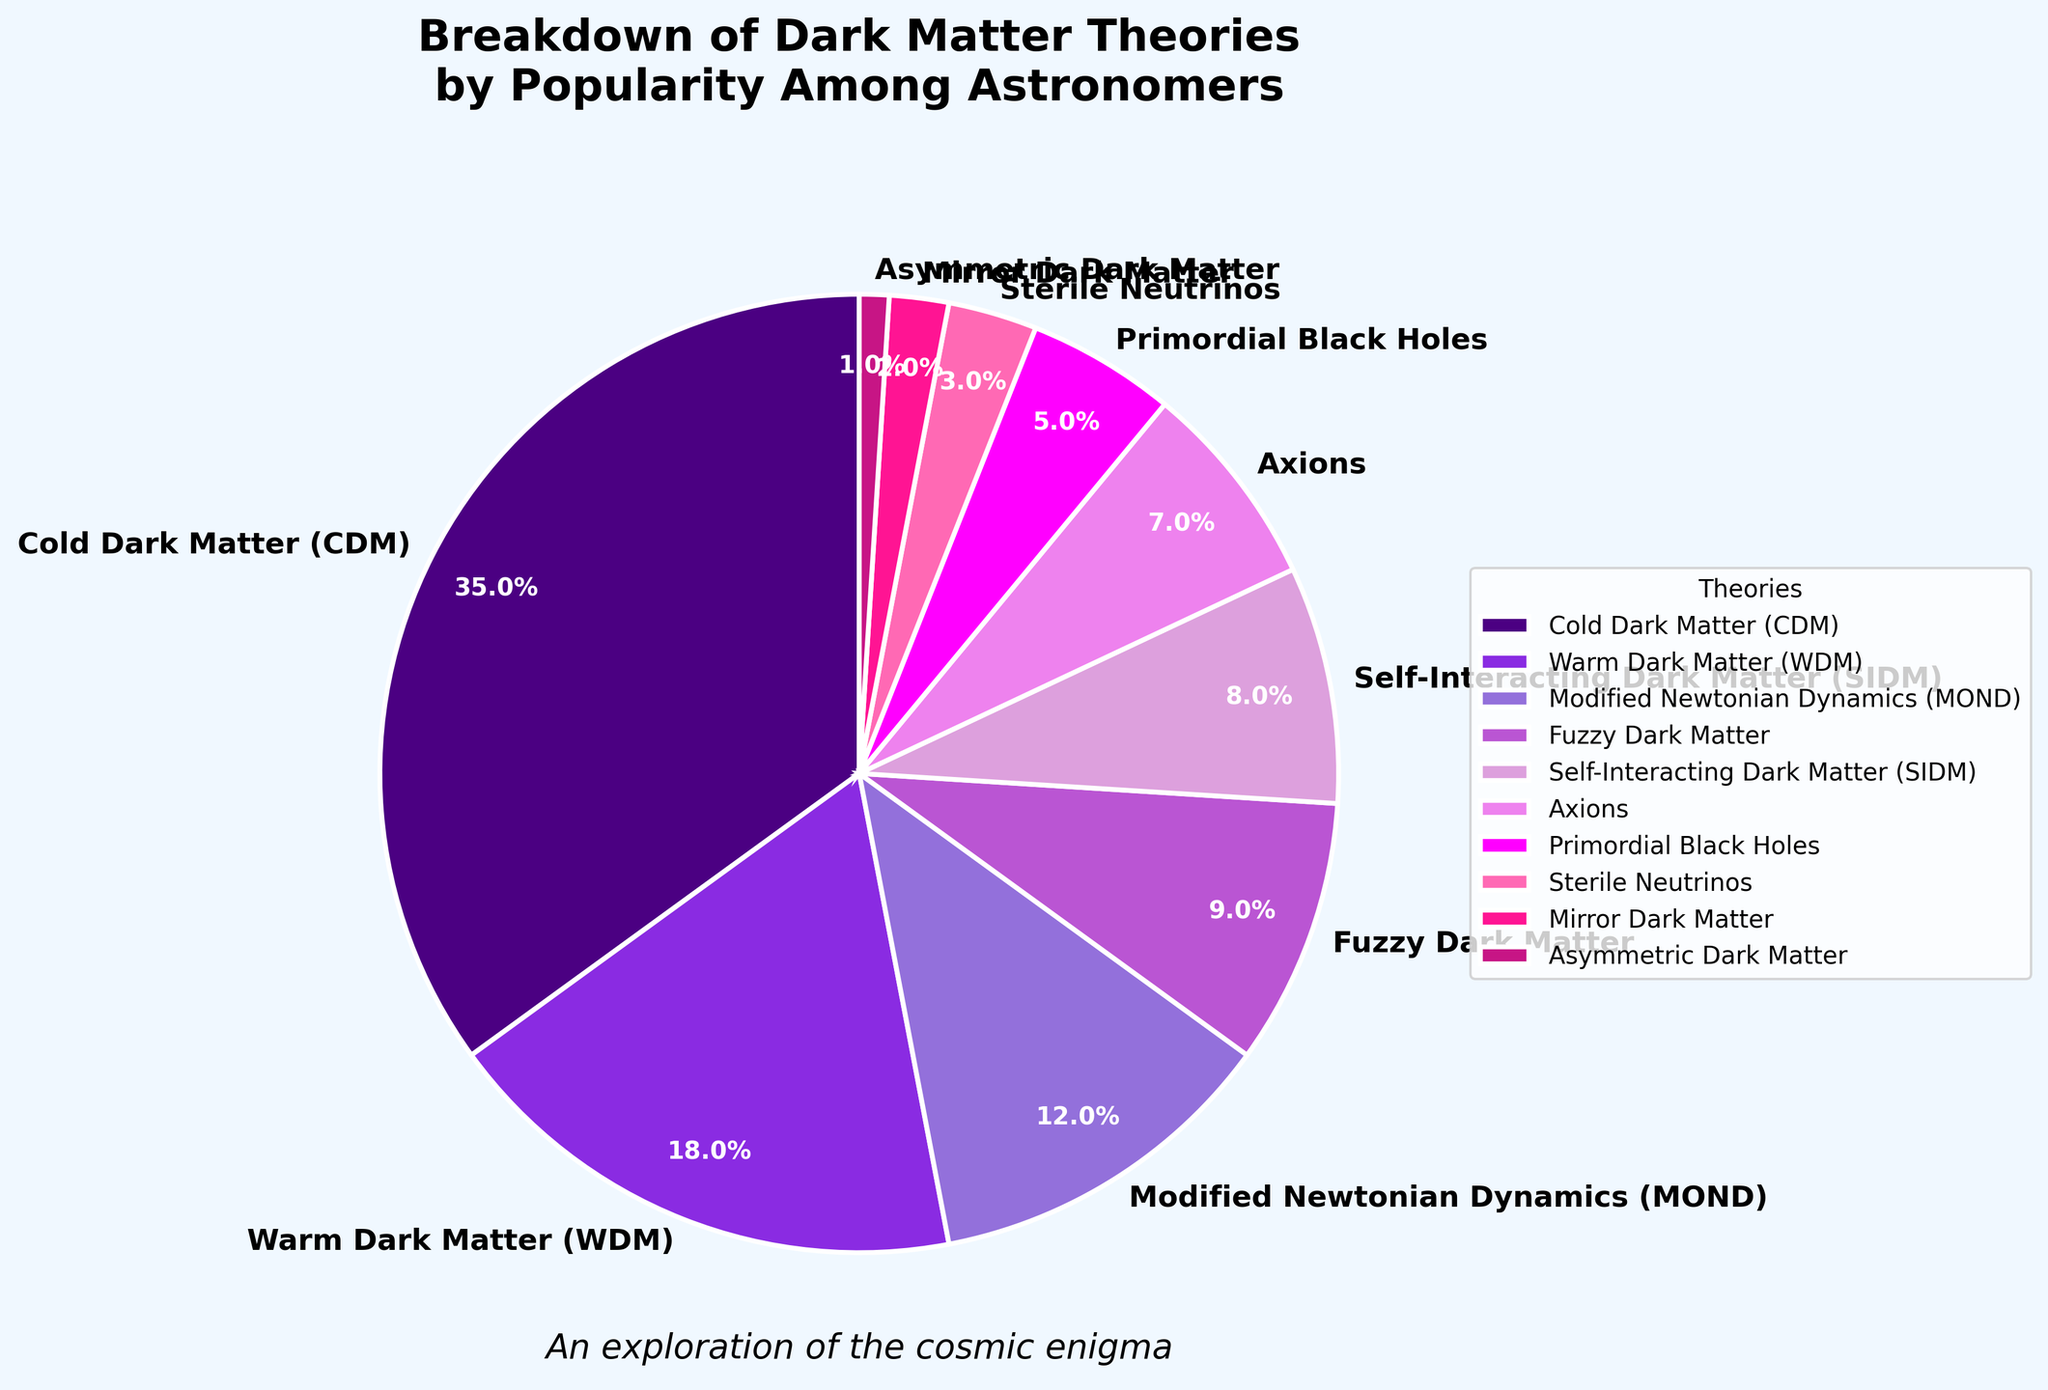What's the most popular dark matter theory? The slice of the pie chart labeled "Cold Dark Matter (CDM)" takes up the largest portion of the chart.
Answer: Cold Dark Matter (CDM) Which two theories together make up less than 5% of the pie chart? The slices labeled "Mirror Dark Matter" and "Asymmetric Dark Matter" both have percentages of 2% and 1%, respectively, which total to 3%.
Answer: Mirror Dark Matter and Asymmetric Dark Matter What is the combined percentage of theories having more than 10% popularity? Theories with more than 10% are Cold Dark Matter (35%) and Warm Dark Matter (18%). Summing these gives 35% + 18% = 53%.
Answer: 53% Between Warm Dark Matter and Fuzzy Dark Matter, which theory is more popular? The percentage for Warm Dark Matter is 18% while Fuzzy Dark Matter is 9%.
Answer: Warm Dark Matter What is the percentage difference between Cold Dark Matter and Axions? Cold Dark Matter has 35% and Axions have 7%, so the difference is 35% - 7% = 28%.
Answer: 28% Identify the theory with the smallest percentage and describe its color visually. The theory with the smallest percentage is Asymmetric Dark Matter at 1%, represented by a dark pink slice.
Answer: Asymmetric Dark Matter, dark pink How does the popularity of Self-Interacting Dark Matter (SIDM) compare to Sterile Neutrinos? SIDM has a popularity of 8% while Sterile Neutrinos have 3%, making SIDM more popular.
Answer: Self-Interacting Dark Matter (SIDM) What is the total percentage of theories that have a popularity of 7% and less? The theories with 7% and less are Axions (7%), Primordial Black Holes (5%), Sterile Neutrinos (3%), Mirror Dark Matter (2%), and Asymmetric Dark Matter (1%). Summing these gives 7% + 5% + 3% + 2% + 1% = 18%.
Answer: 18% Which section of the pie chart is represented in purple shades? The sections for Warm Dark Matter (18%), Modified Newtonian Dynamics (12%), and Fuzzy Dark Matter (9%) are shown in varying shades of purple.
Answer: Warm Dark Matter, Modified Newtonian Dynamics, Fuzzy Dark Matter How many theories have a percentage between 5% and 15%? Theories within the 5%-15% range include Warm Dark Matter (18%), Modified Newtonian Dynamics (12%), Fuzzy Dark Matter (9%), and Self-Interacting Dark Matter (8%).
Answer: 4 